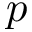<formula> <loc_0><loc_0><loc_500><loc_500>p</formula> 